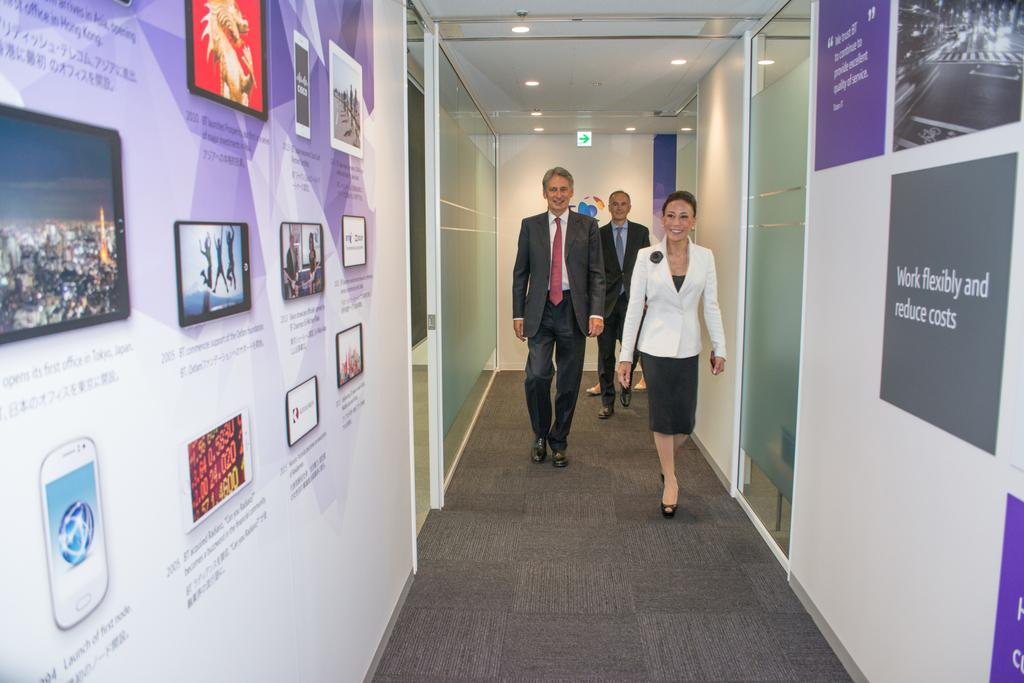Provide a one-sentence caption for the provided image. A number of posters adorn a hallway with encourages slogans like Work Flexibility and Fixed Costs. 